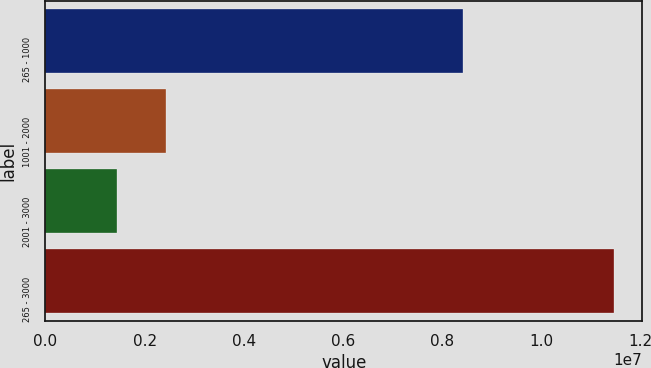Convert chart to OTSL. <chart><loc_0><loc_0><loc_500><loc_500><bar_chart><fcel>265 - 1000<fcel>1001 - 2000<fcel>2001 - 3000<fcel>265 - 3000<nl><fcel>8.42523e+06<fcel>2.43891e+06<fcel>1.4366e+06<fcel>1.14597e+07<nl></chart> 